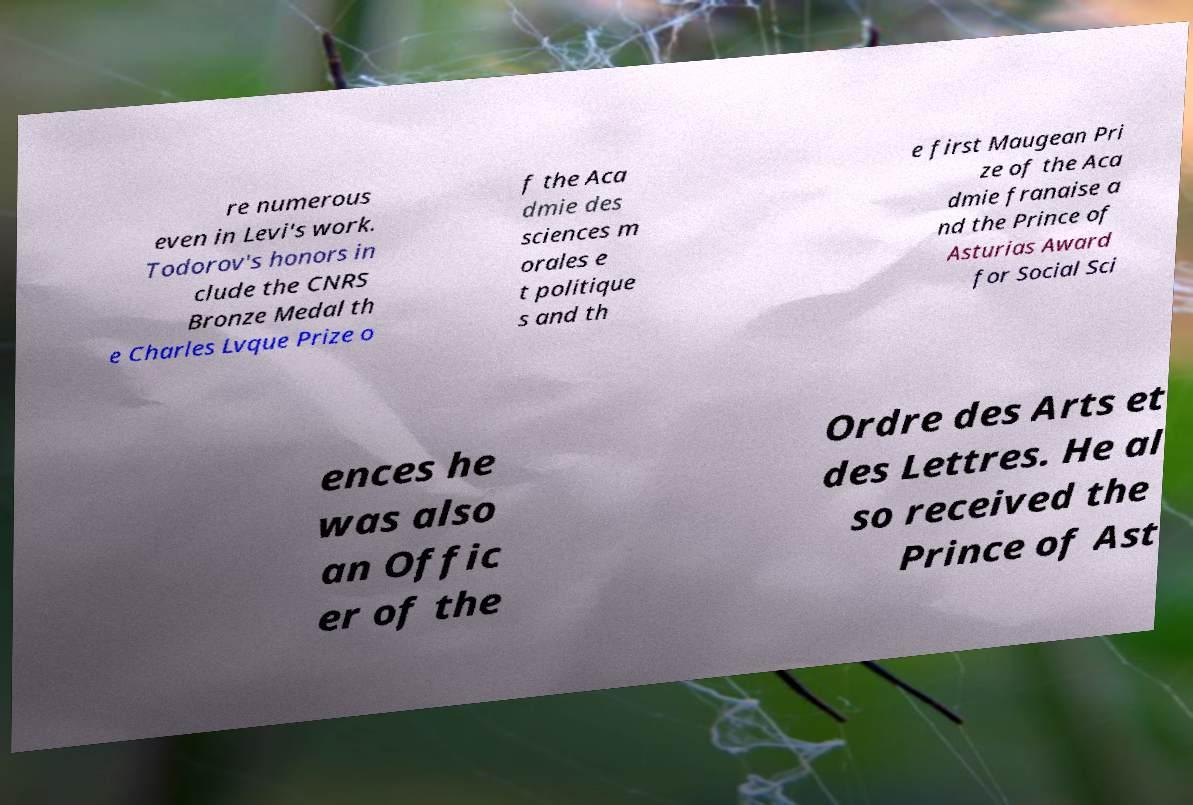For documentation purposes, I need the text within this image transcribed. Could you provide that? re numerous even in Levi's work. Todorov's honors in clude the CNRS Bronze Medal th e Charles Lvque Prize o f the Aca dmie des sciences m orales e t politique s and th e first Maugean Pri ze of the Aca dmie franaise a nd the Prince of Asturias Award for Social Sci ences he was also an Offic er of the Ordre des Arts et des Lettres. He al so received the Prince of Ast 